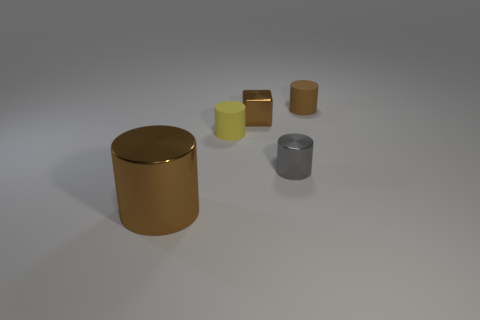Subtract all yellow matte cylinders. How many cylinders are left? 3 Add 4 tiny gray metallic cylinders. How many objects exist? 9 Subtract 3 cylinders. How many cylinders are left? 1 Subtract all gray cylinders. How many cylinders are left? 3 Subtract all blocks. How many objects are left? 4 Subtract all yellow cylinders. Subtract all red cubes. How many cylinders are left? 3 Subtract all green spheres. How many brown cylinders are left? 2 Subtract all yellow matte objects. Subtract all gray cylinders. How many objects are left? 3 Add 1 big metallic cylinders. How many big metallic cylinders are left? 2 Add 1 small shiny blocks. How many small shiny blocks exist? 2 